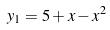<formula> <loc_0><loc_0><loc_500><loc_500>y _ { 1 } = 5 + x - x ^ { 2 }</formula> 